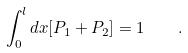Convert formula to latex. <formula><loc_0><loc_0><loc_500><loc_500>\int _ { 0 } ^ { l } d x [ P _ { 1 } + P _ { 2 } ] = 1 \quad .</formula> 